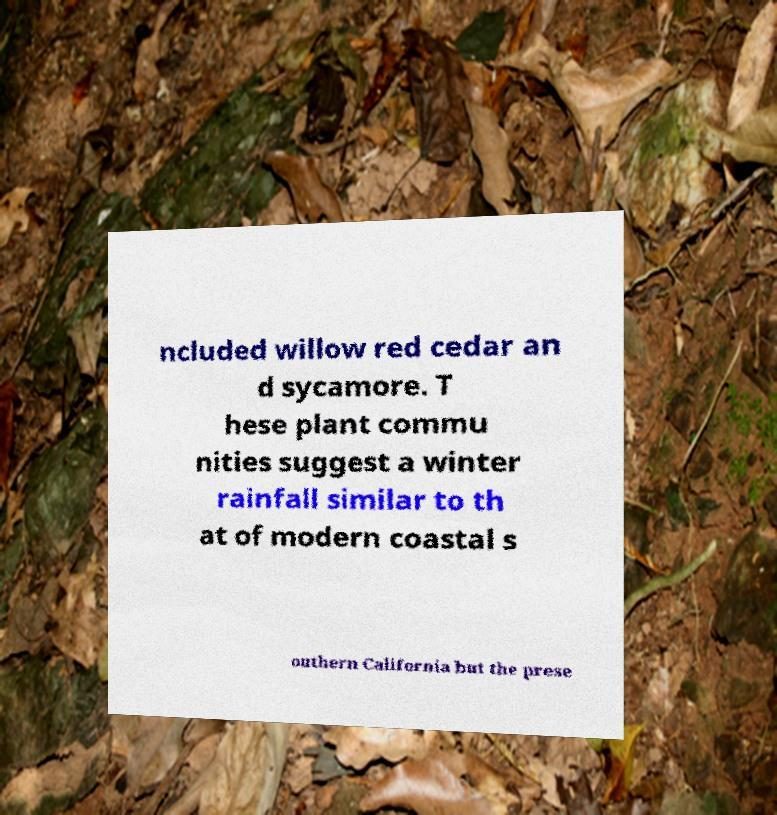What messages or text are displayed in this image? I need them in a readable, typed format. ncluded willow red cedar an d sycamore. T hese plant commu nities suggest a winter rainfall similar to th at of modern coastal s outhern California but the prese 